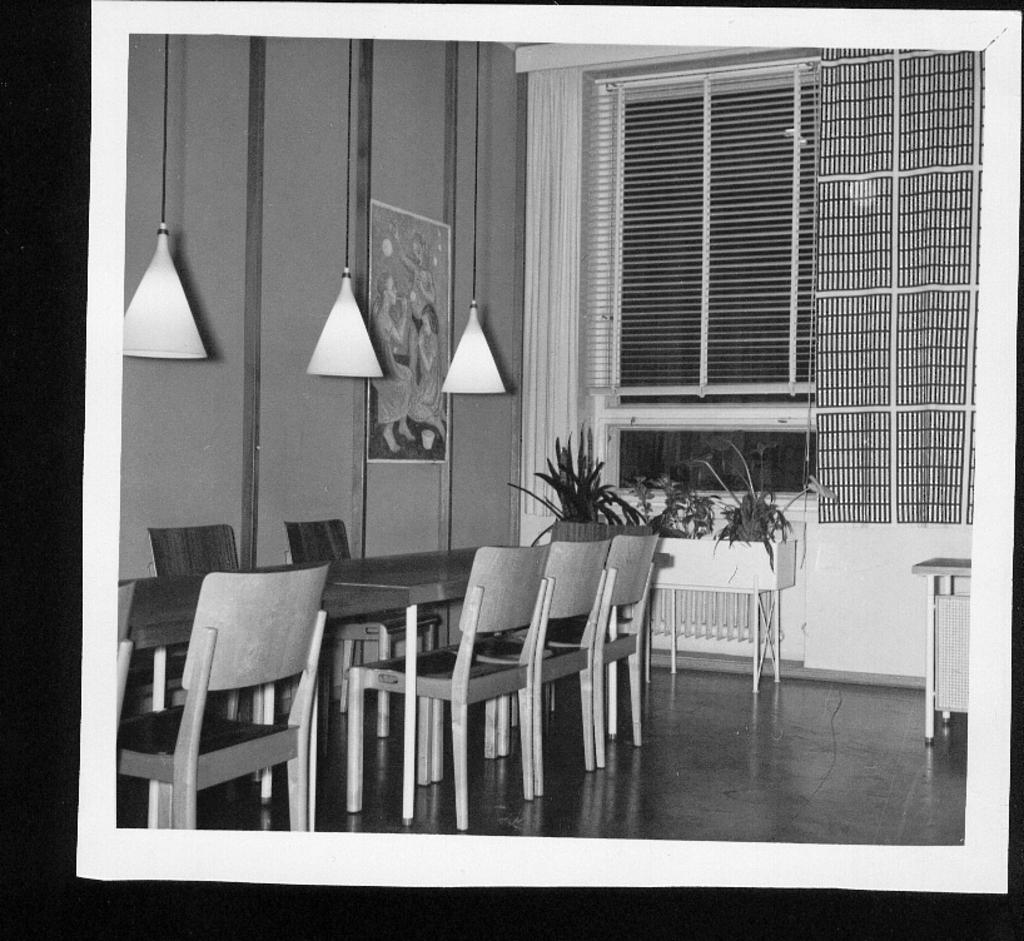What is the color scheme of the image? The image is black and white. What type of furniture can be seen in the image? There are chairs and tables in the image. What decorative items are present in the image? There are flower pots and a poster on the wall in the image. What type of lighting is present in the image? There are ceiling lights in the image. What type of window treatment is present in the image? There are curtains and blinds on the glass windows in the background of the image. How many quarters can be seen on the floor in the image? There are no quarters visible on the floor in the image. What type of sticks are used to support the tree in the image? There is no tree present in the image, so there are no sticks used to support it. 